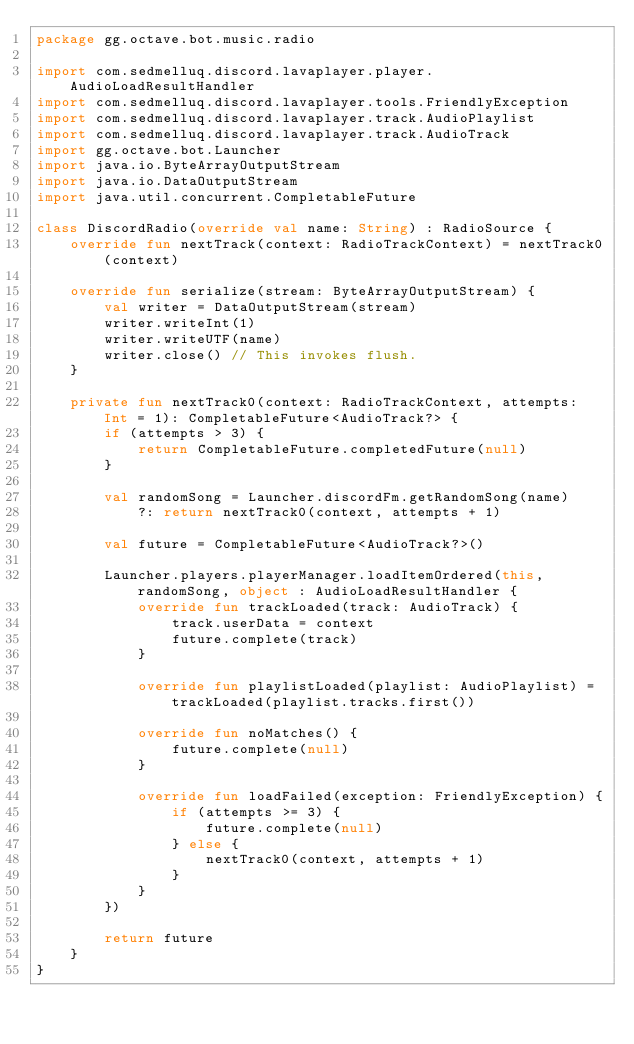Convert code to text. <code><loc_0><loc_0><loc_500><loc_500><_Kotlin_>package gg.octave.bot.music.radio

import com.sedmelluq.discord.lavaplayer.player.AudioLoadResultHandler
import com.sedmelluq.discord.lavaplayer.tools.FriendlyException
import com.sedmelluq.discord.lavaplayer.track.AudioPlaylist
import com.sedmelluq.discord.lavaplayer.track.AudioTrack
import gg.octave.bot.Launcher
import java.io.ByteArrayOutputStream
import java.io.DataOutputStream
import java.util.concurrent.CompletableFuture

class DiscordRadio(override val name: String) : RadioSource {
    override fun nextTrack(context: RadioTrackContext) = nextTrack0(context)

    override fun serialize(stream: ByteArrayOutputStream) {
        val writer = DataOutputStream(stream)
        writer.writeInt(1)
        writer.writeUTF(name)
        writer.close() // This invokes flush.
    }

    private fun nextTrack0(context: RadioTrackContext, attempts: Int = 1): CompletableFuture<AudioTrack?> {
        if (attempts > 3) {
            return CompletableFuture.completedFuture(null)
        }

        val randomSong = Launcher.discordFm.getRandomSong(name)
            ?: return nextTrack0(context, attempts + 1)

        val future = CompletableFuture<AudioTrack?>()

        Launcher.players.playerManager.loadItemOrdered(this, randomSong, object : AudioLoadResultHandler {
            override fun trackLoaded(track: AudioTrack) {
                track.userData = context
                future.complete(track)
            }

            override fun playlistLoaded(playlist: AudioPlaylist) = trackLoaded(playlist.tracks.first())

            override fun noMatches() {
                future.complete(null)
            }

            override fun loadFailed(exception: FriendlyException) {
                if (attempts >= 3) {
                    future.complete(null)
                } else {
                    nextTrack0(context, attempts + 1)
                }
            }
        })

        return future
    }
}
</code> 